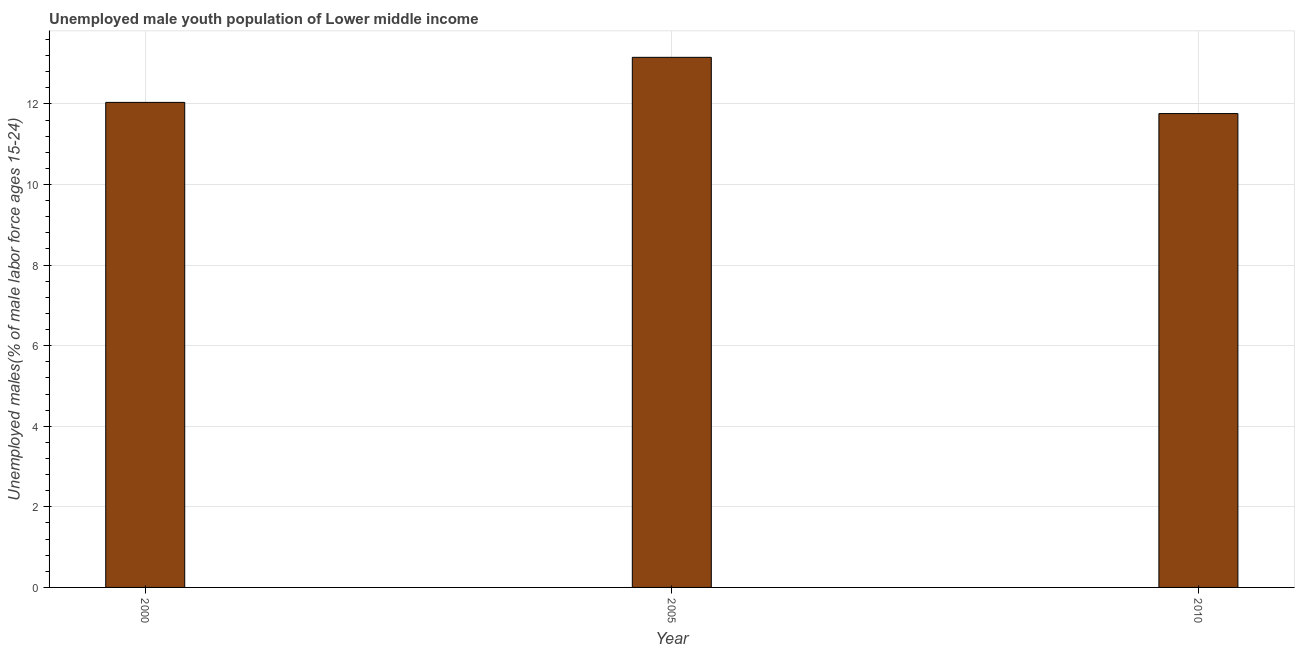Does the graph contain any zero values?
Your answer should be very brief. No. Does the graph contain grids?
Your response must be concise. Yes. What is the title of the graph?
Make the answer very short. Unemployed male youth population of Lower middle income. What is the label or title of the Y-axis?
Provide a succinct answer. Unemployed males(% of male labor force ages 15-24). What is the unemployed male youth in 2010?
Provide a short and direct response. 11.76. Across all years, what is the maximum unemployed male youth?
Offer a very short reply. 13.16. Across all years, what is the minimum unemployed male youth?
Keep it short and to the point. 11.76. What is the sum of the unemployed male youth?
Make the answer very short. 36.96. What is the difference between the unemployed male youth in 2005 and 2010?
Ensure brevity in your answer.  1.4. What is the average unemployed male youth per year?
Your answer should be compact. 12.32. What is the median unemployed male youth?
Your response must be concise. 12.04. What is the ratio of the unemployed male youth in 2005 to that in 2010?
Provide a short and direct response. 1.12. What is the difference between the highest and the second highest unemployed male youth?
Keep it short and to the point. 1.12. In how many years, is the unemployed male youth greater than the average unemployed male youth taken over all years?
Your answer should be very brief. 1. Are all the bars in the graph horizontal?
Provide a succinct answer. No. What is the difference between two consecutive major ticks on the Y-axis?
Keep it short and to the point. 2. What is the Unemployed males(% of male labor force ages 15-24) in 2000?
Your response must be concise. 12.04. What is the Unemployed males(% of male labor force ages 15-24) of 2005?
Offer a terse response. 13.16. What is the Unemployed males(% of male labor force ages 15-24) in 2010?
Your response must be concise. 11.76. What is the difference between the Unemployed males(% of male labor force ages 15-24) in 2000 and 2005?
Provide a short and direct response. -1.12. What is the difference between the Unemployed males(% of male labor force ages 15-24) in 2000 and 2010?
Your response must be concise. 0.28. What is the difference between the Unemployed males(% of male labor force ages 15-24) in 2005 and 2010?
Offer a very short reply. 1.4. What is the ratio of the Unemployed males(% of male labor force ages 15-24) in 2000 to that in 2005?
Offer a very short reply. 0.92. What is the ratio of the Unemployed males(% of male labor force ages 15-24) in 2005 to that in 2010?
Your answer should be very brief. 1.12. 